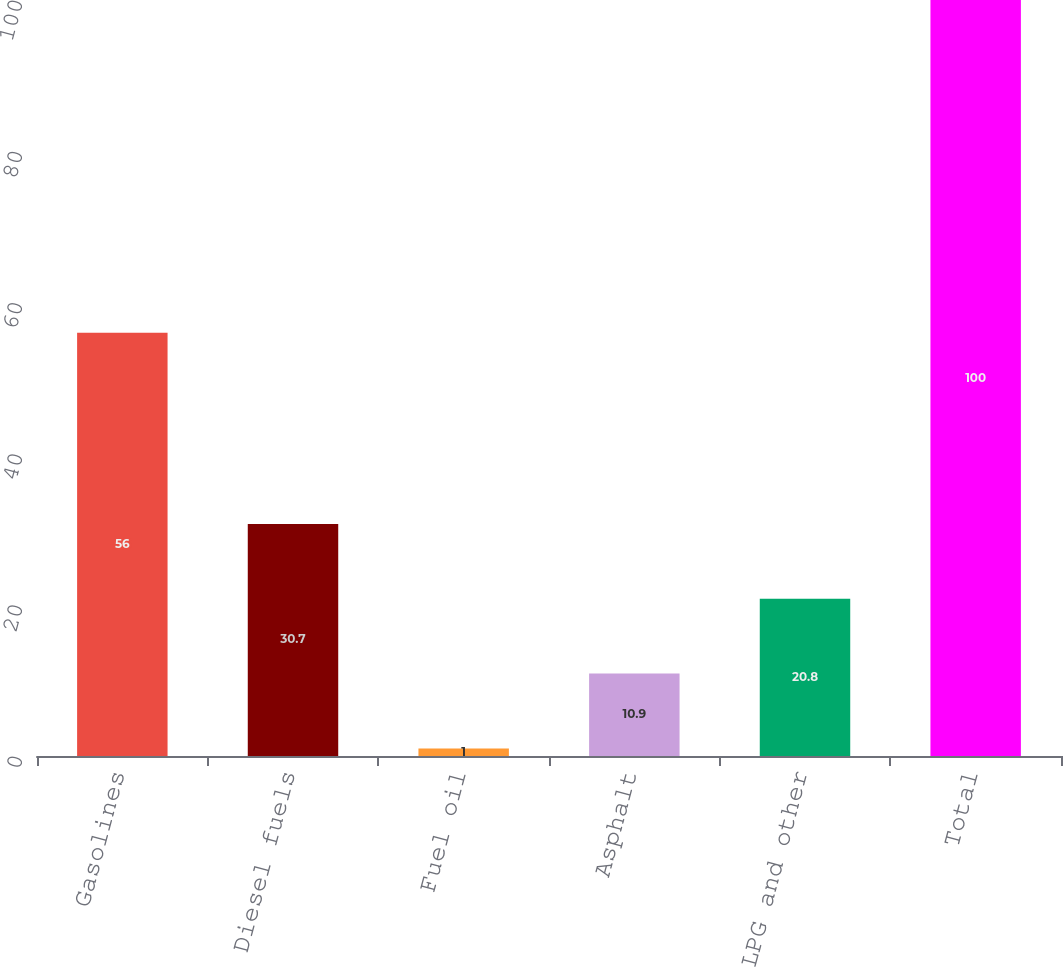Convert chart to OTSL. <chart><loc_0><loc_0><loc_500><loc_500><bar_chart><fcel>Gasolines<fcel>Diesel fuels<fcel>Fuel oil<fcel>Asphalt<fcel>LPG and other<fcel>Total<nl><fcel>56<fcel>30.7<fcel>1<fcel>10.9<fcel>20.8<fcel>100<nl></chart> 